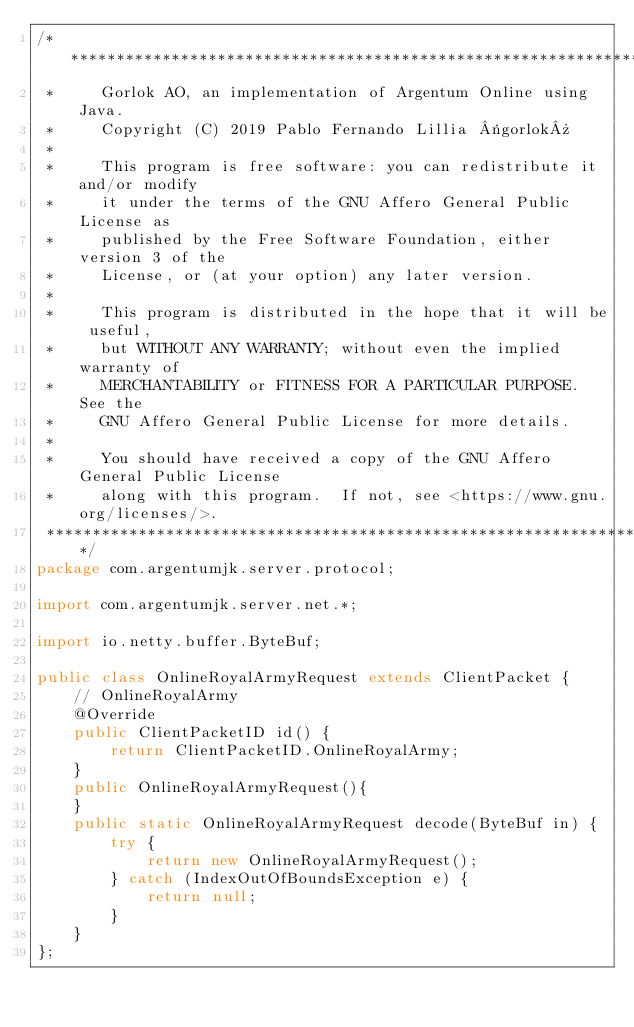<code> <loc_0><loc_0><loc_500><loc_500><_Java_>/*******************************************************************************
 *     Gorlok AO, an implementation of Argentum Online using Java.
 *     Copyright (C) 2019 Pablo Fernando Lillia «gorlok» 
 *
 *     This program is free software: you can redistribute it and/or modify
 *     it under the terms of the GNU Affero General Public License as
 *     published by the Free Software Foundation, either version 3 of the
 *     License, or (at your option) any later version.
 *
 *     This program is distributed in the hope that it will be useful,
 *     but WITHOUT ANY WARRANTY; without even the implied warranty of
 *     MERCHANTABILITY or FITNESS FOR A PARTICULAR PURPOSE.  See the
 *     GNU Affero General Public License for more details.
 *
 *     You should have received a copy of the GNU Affero General Public License
 *     along with this program.  If not, see <https://www.gnu.org/licenses/>.
 *******************************************************************************/
package com.argentumjk.server.protocol;

import com.argentumjk.server.net.*;

import io.netty.buffer.ByteBuf;

public class OnlineRoyalArmyRequest extends ClientPacket {
	// OnlineRoyalArmy
	@Override
	public ClientPacketID id() {
		return ClientPacketID.OnlineRoyalArmy;
	}
	public OnlineRoyalArmyRequest(){
	}
	public static OnlineRoyalArmyRequest decode(ByteBuf in) {    
		try {                                   
			return new OnlineRoyalArmyRequest();                  
		} catch (IndexOutOfBoundsException e) { 
			return null;                        
		}                                       
	}                                        
};

</code> 